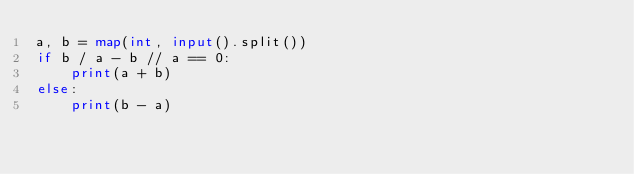<code> <loc_0><loc_0><loc_500><loc_500><_Python_>a, b = map(int, input().split())
if b / a - b // a == 0:
    print(a + b)
else:
    print(b - a)
</code> 